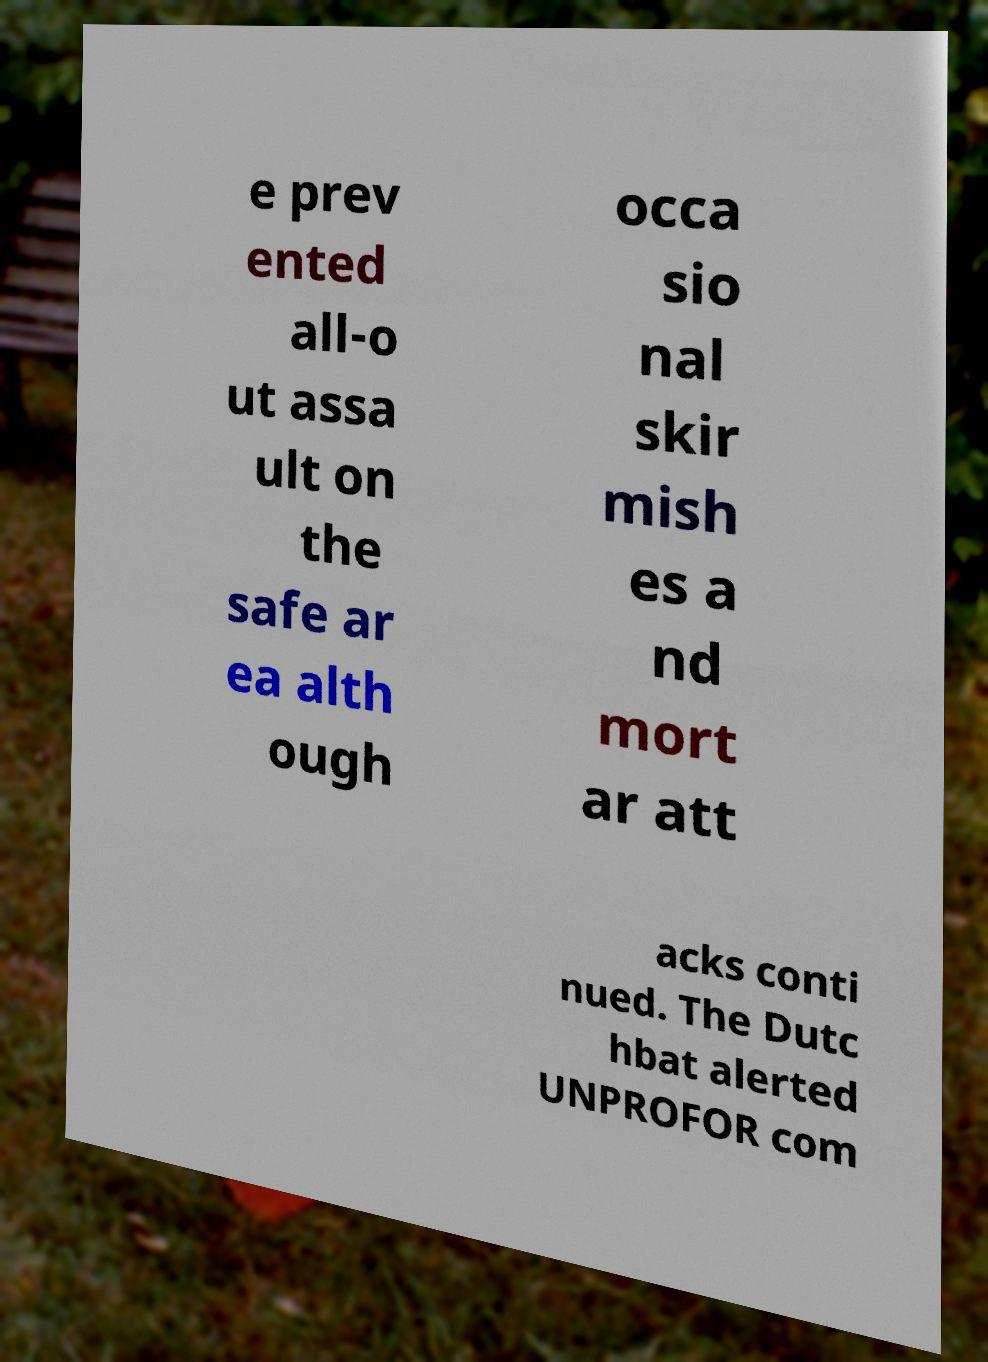Could you extract and type out the text from this image? e prev ented all-o ut assa ult on the safe ar ea alth ough occa sio nal skir mish es a nd mort ar att acks conti nued. The Dutc hbat alerted UNPROFOR com 